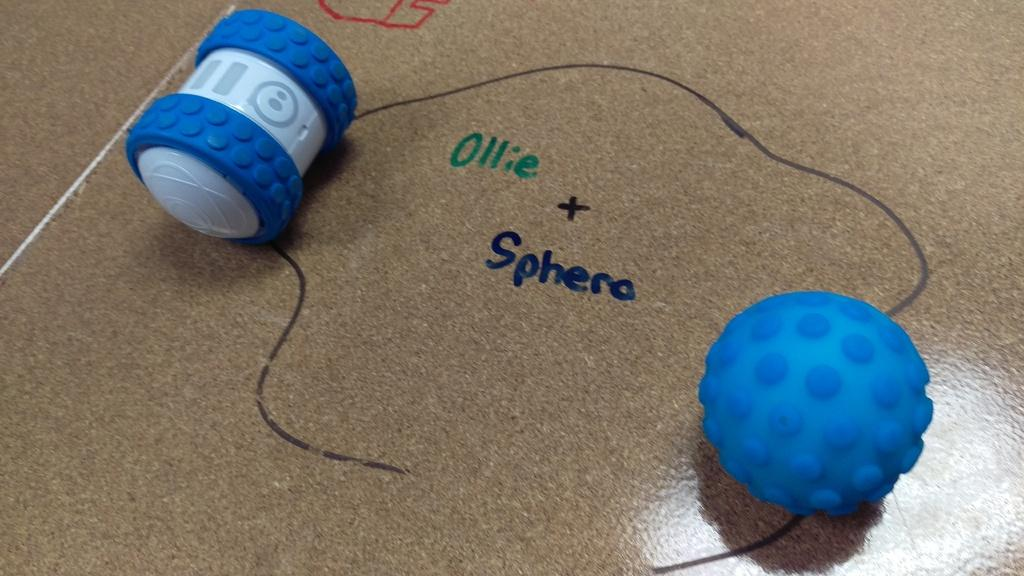<image>
Offer a succinct explanation of the picture presented. The words "Ollie & Sphero" written on a glossy tan surface 